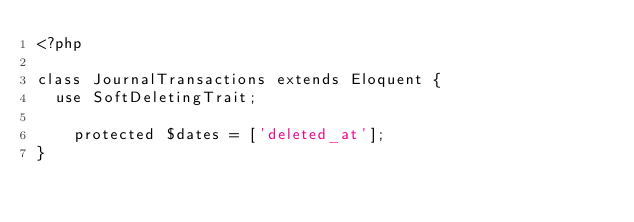<code> <loc_0><loc_0><loc_500><loc_500><_PHP_><?php

class JournalTransactions extends Eloquent {
	use SoftDeletingTrait;

    protected $dates = ['deleted_at'];
}</code> 